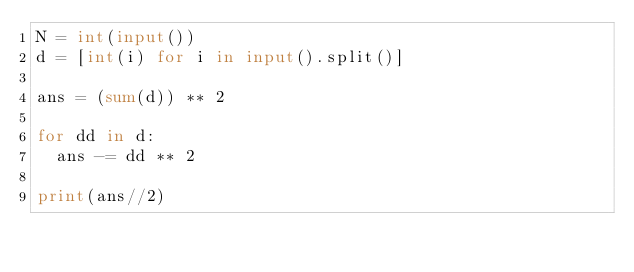Convert code to text. <code><loc_0><loc_0><loc_500><loc_500><_Python_>N = int(input())
d = [int(i) for i in input().split()]

ans = (sum(d)) ** 2

for dd in d:
  ans -= dd ** 2

print(ans//2)</code> 